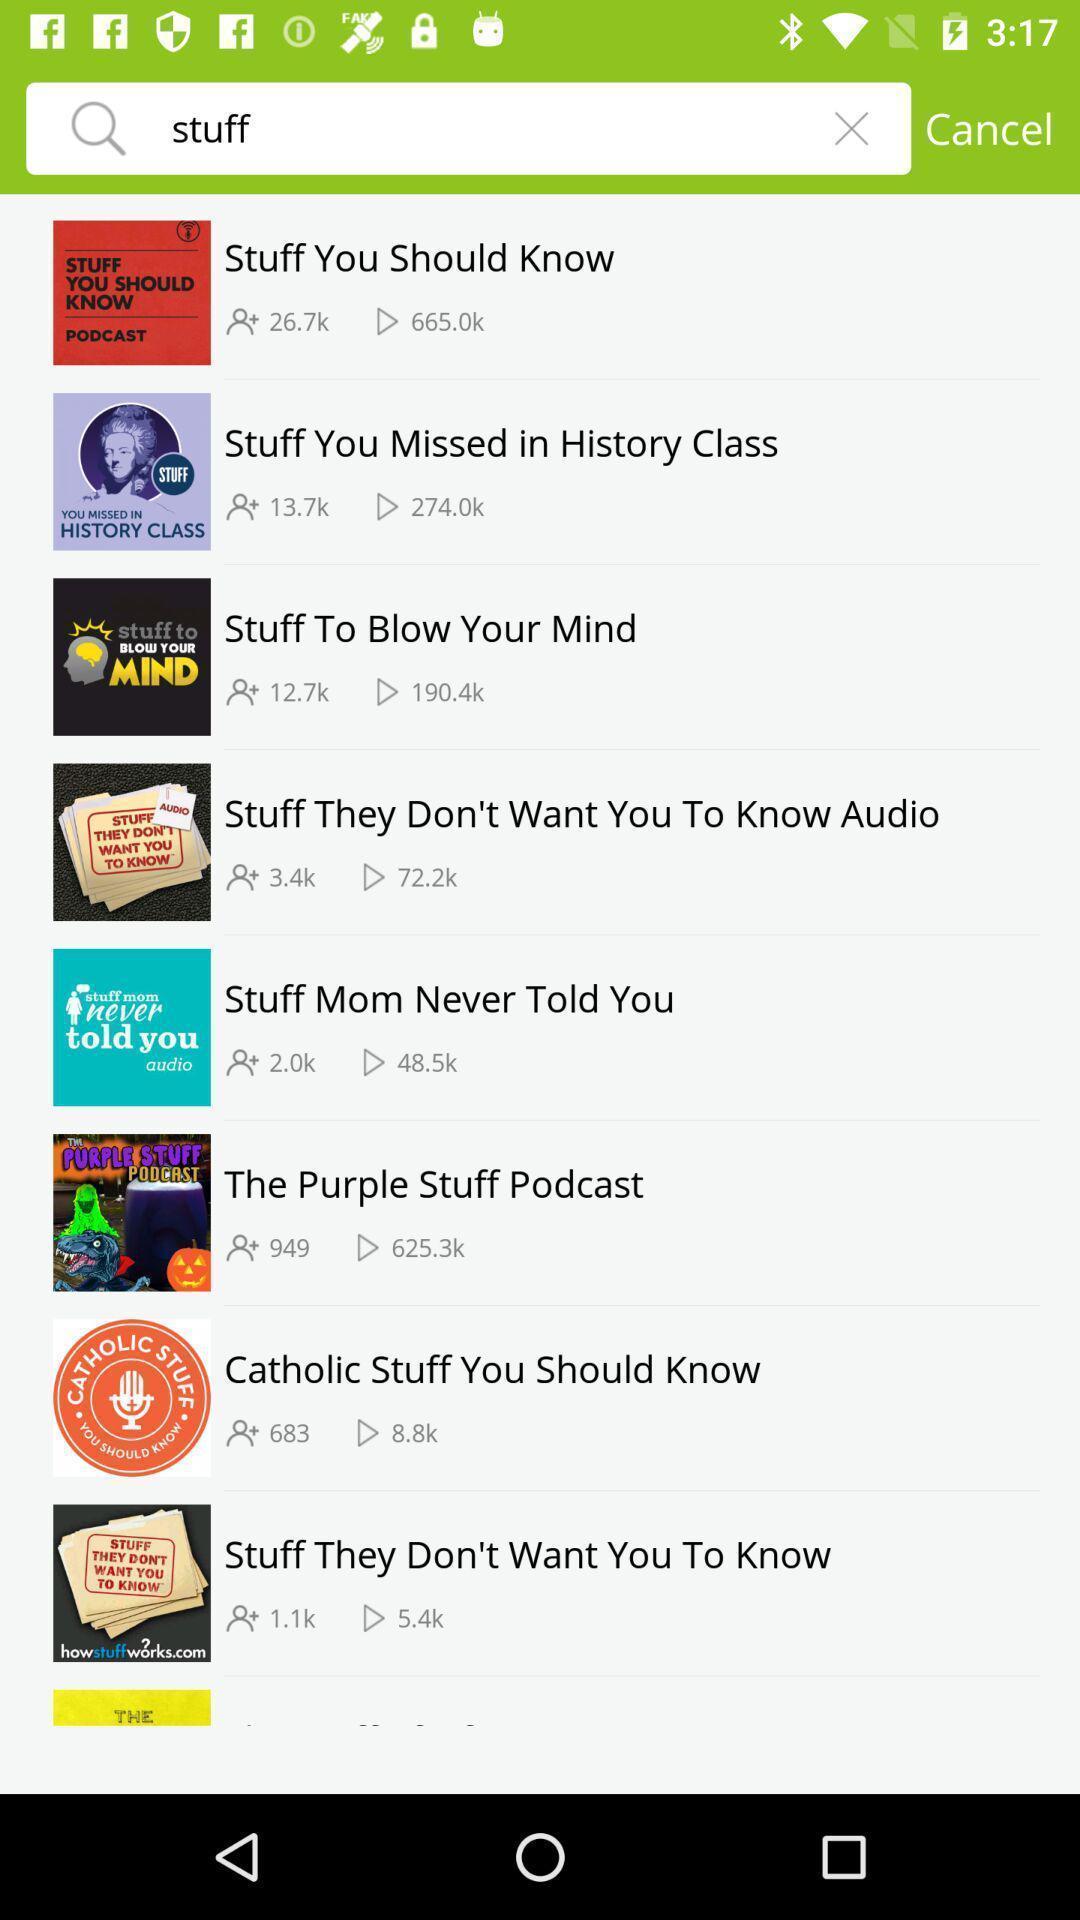Tell me what you see in this picture. Screen shows search results of stuff. 